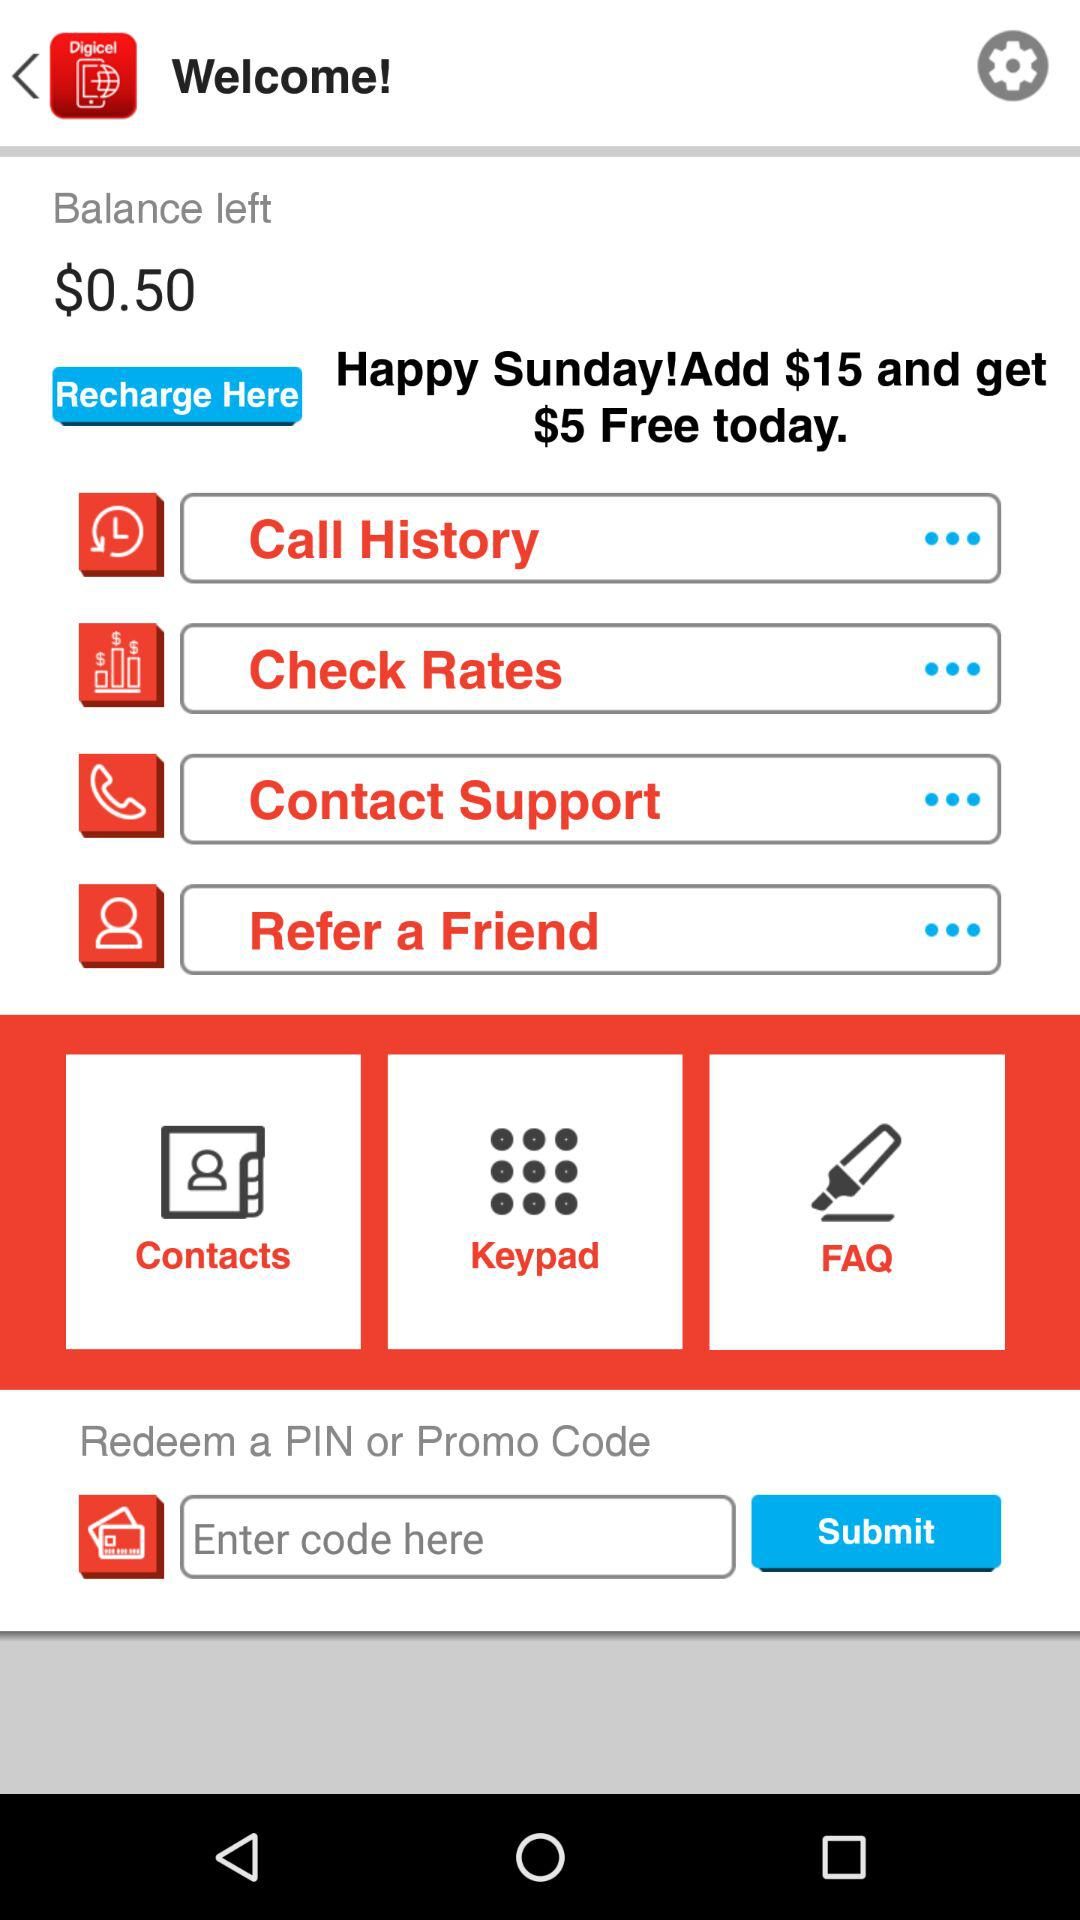How much balance is left? The left balance is $0.50. 